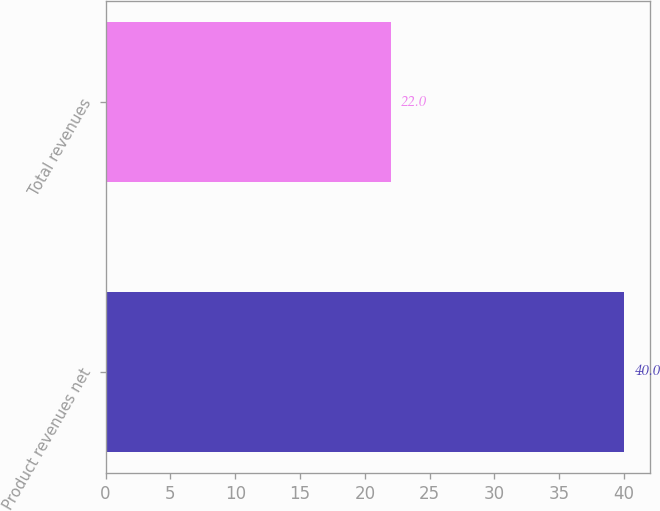Convert chart to OTSL. <chart><loc_0><loc_0><loc_500><loc_500><bar_chart><fcel>Product revenues net<fcel>Total revenues<nl><fcel>40<fcel>22<nl></chart> 